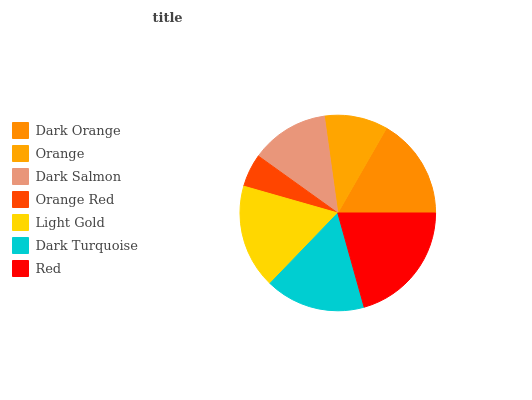Is Orange Red the minimum?
Answer yes or no. Yes. Is Red the maximum?
Answer yes or no. Yes. Is Orange the minimum?
Answer yes or no. No. Is Orange the maximum?
Answer yes or no. No. Is Dark Orange greater than Orange?
Answer yes or no. Yes. Is Orange less than Dark Orange?
Answer yes or no. Yes. Is Orange greater than Dark Orange?
Answer yes or no. No. Is Dark Orange less than Orange?
Answer yes or no. No. Is Dark Turquoise the high median?
Answer yes or no. Yes. Is Dark Turquoise the low median?
Answer yes or no. Yes. Is Light Gold the high median?
Answer yes or no. No. Is Orange Red the low median?
Answer yes or no. No. 